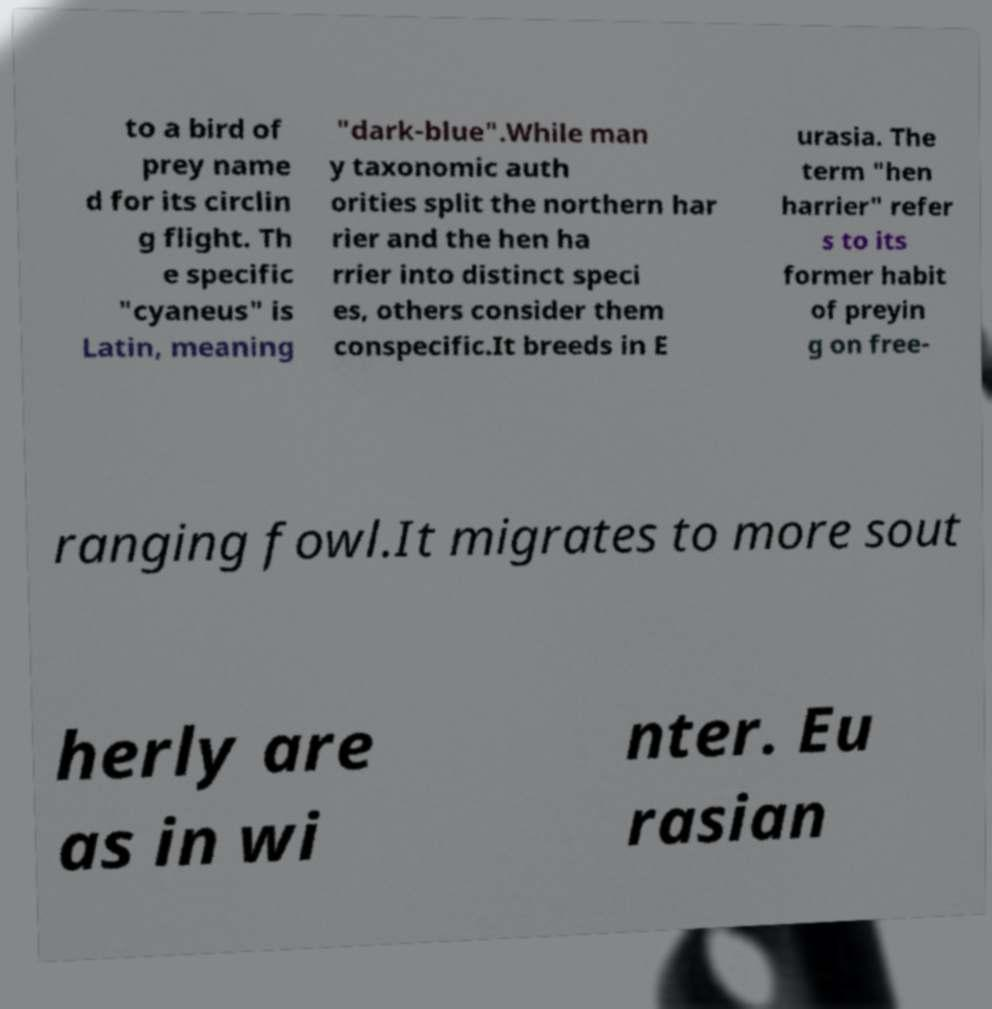What messages or text are displayed in this image? I need them in a readable, typed format. to a bird of prey name d for its circlin g flight. Th e specific "cyaneus" is Latin, meaning "dark-blue".While man y taxonomic auth orities split the northern har rier and the hen ha rrier into distinct speci es, others consider them conspecific.It breeds in E urasia. The term "hen harrier" refer s to its former habit of preyin g on free- ranging fowl.It migrates to more sout herly are as in wi nter. Eu rasian 